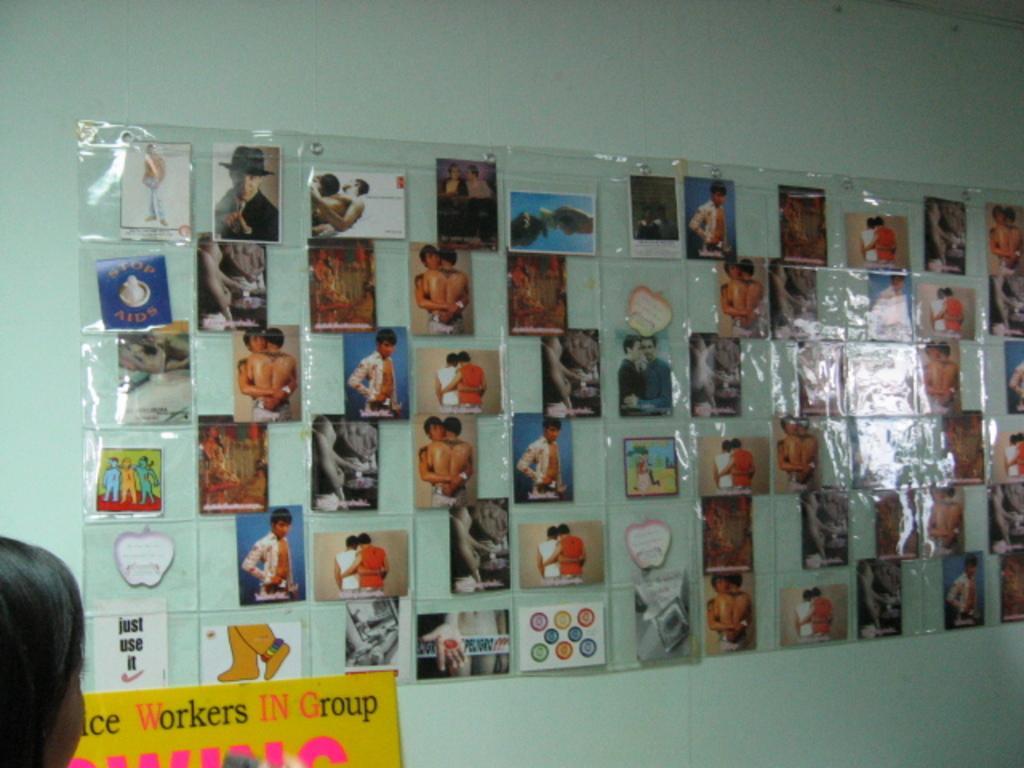In one or two sentences, can you explain what this image depicts? In this picture I can see number of photos laminated on the wall and on the left bottom corner of this picture I can see a person's head and I see something is written on a board. 